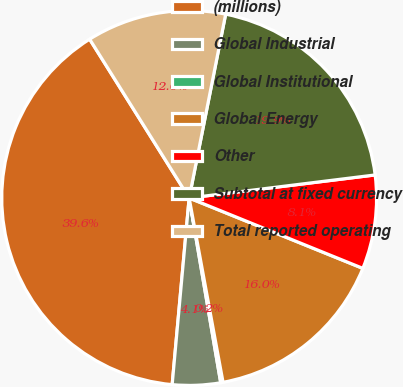Convert chart to OTSL. <chart><loc_0><loc_0><loc_500><loc_500><pie_chart><fcel>(millions)<fcel>Global Industrial<fcel>Global Institutional<fcel>Global Energy<fcel>Other<fcel>Subtotal at fixed currency<fcel>Total reported operating<nl><fcel>39.65%<fcel>4.14%<fcel>0.2%<fcel>15.98%<fcel>8.09%<fcel>19.92%<fcel>12.03%<nl></chart> 